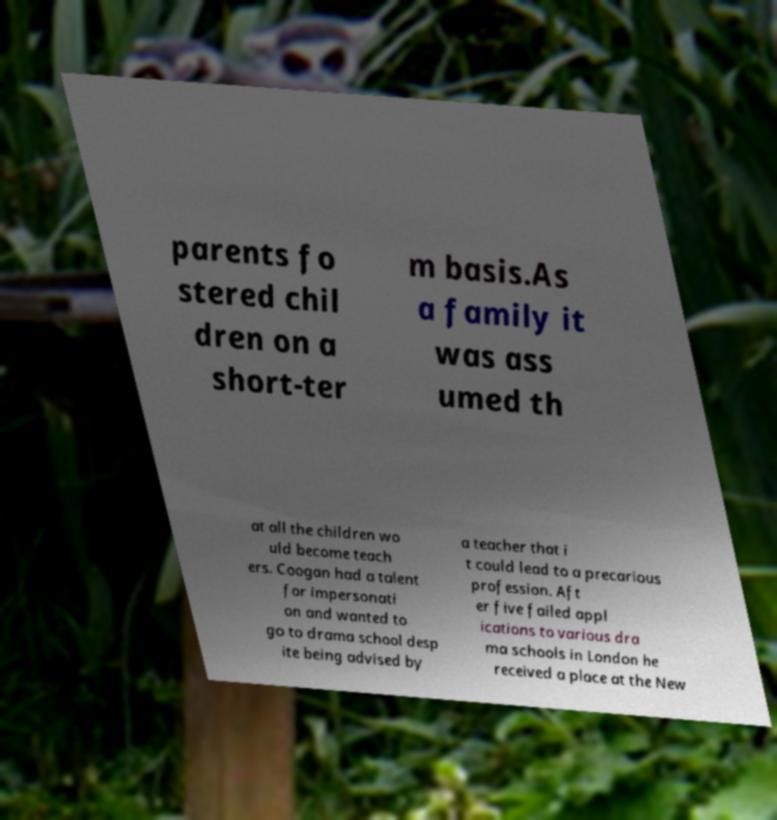What messages or text are displayed in this image? I need them in a readable, typed format. parents fo stered chil dren on a short-ter m basis.As a family it was ass umed th at all the children wo uld become teach ers. Coogan had a talent for impersonati on and wanted to go to drama school desp ite being advised by a teacher that i t could lead to a precarious profession. Aft er five failed appl ications to various dra ma schools in London he received a place at the New 